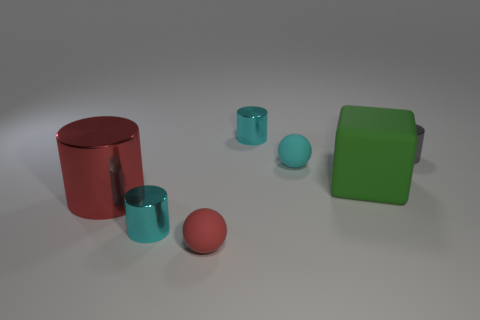Are there an equal number of small matte objects that are behind the big green cube and gray metal cylinders?
Provide a short and direct response. Yes. How many things are either big red metallic things or matte blocks?
Your answer should be compact. 2. Are there any other things that are the same shape as the large metal object?
Provide a short and direct response. Yes. There is a big thing that is on the right side of the small red object that is in front of the green object; what is its shape?
Give a very brief answer. Cube. There is a tiny red thing that is the same material as the big green block; what shape is it?
Make the answer very short. Sphere. There is a gray thing to the right of the thing that is behind the tiny gray shiny cylinder; what size is it?
Your response must be concise. Small. The red matte thing is what shape?
Offer a terse response. Sphere. What number of small objects are either purple matte balls or cyan objects?
Make the answer very short. 3. There is a red metallic object that is the same shape as the gray object; what size is it?
Offer a very short reply. Large. How many cylinders are both on the left side of the green rubber cube and behind the large red shiny cylinder?
Your answer should be compact. 1. 